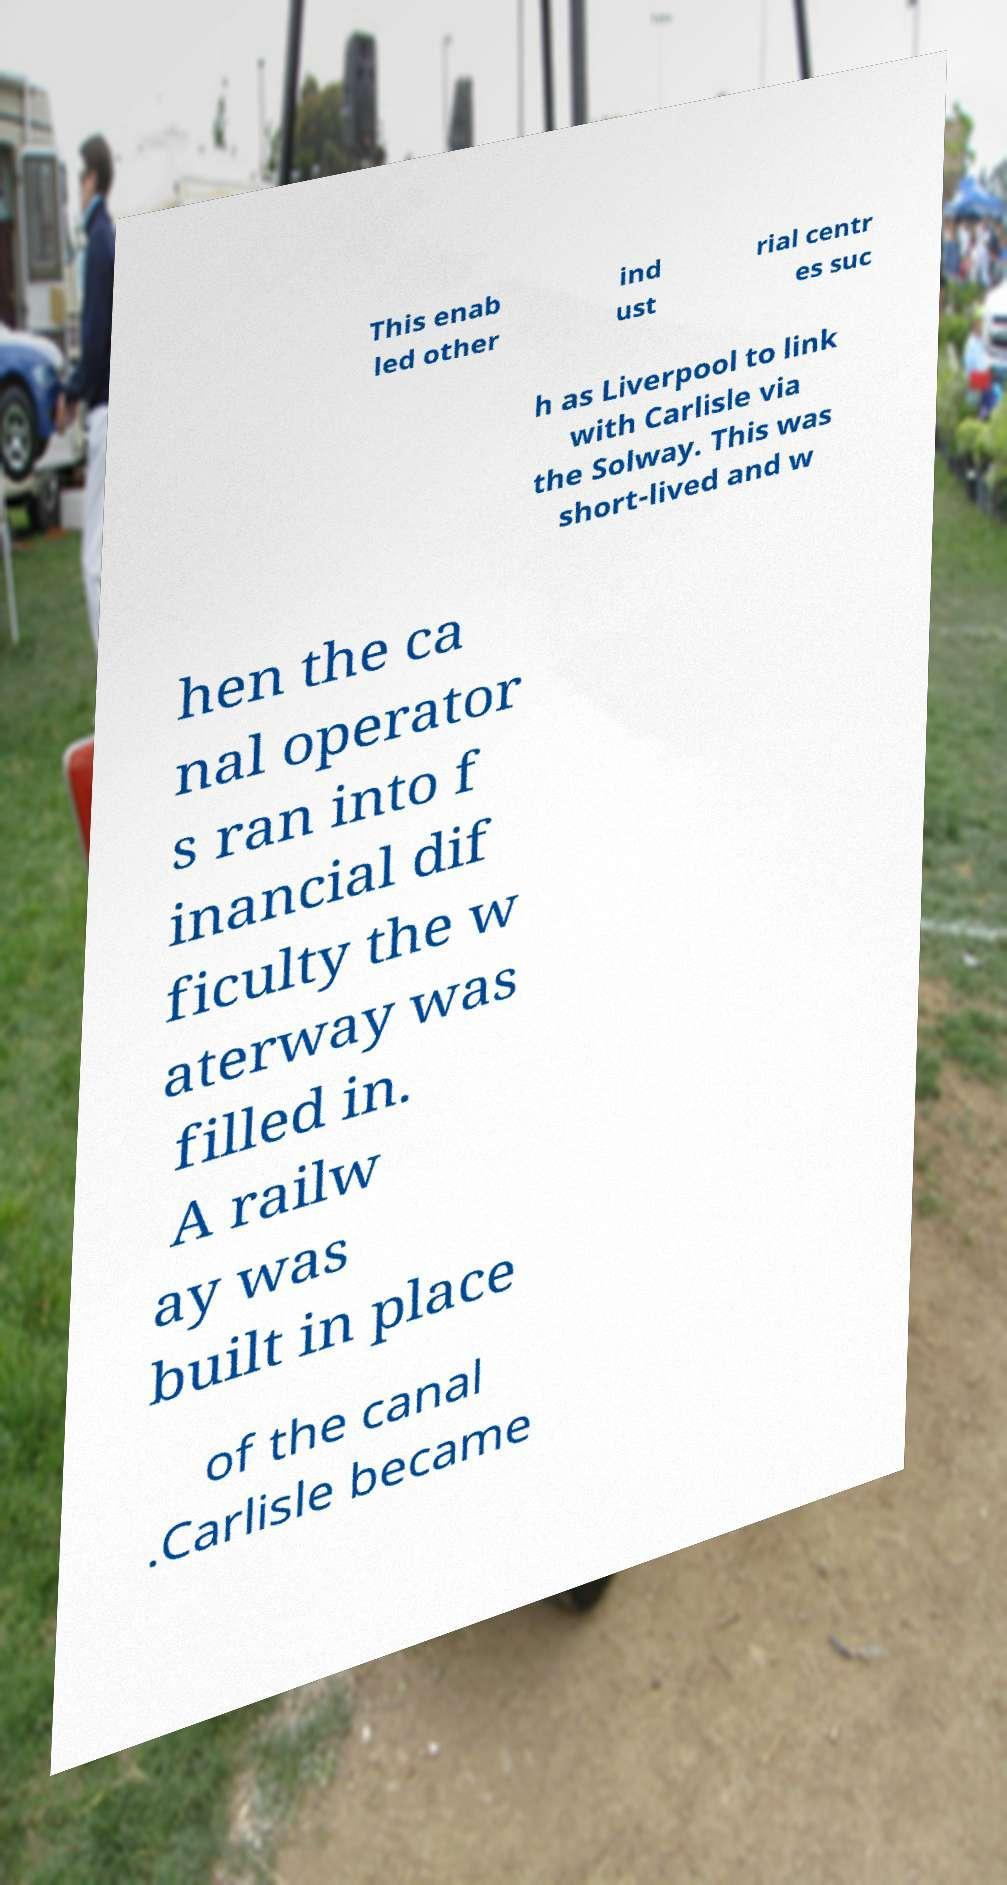What messages or text are displayed in this image? I need them in a readable, typed format. This enab led other ind ust rial centr es suc h as Liverpool to link with Carlisle via the Solway. This was short-lived and w hen the ca nal operator s ran into f inancial dif ficulty the w aterway was filled in. A railw ay was built in place of the canal .Carlisle became 